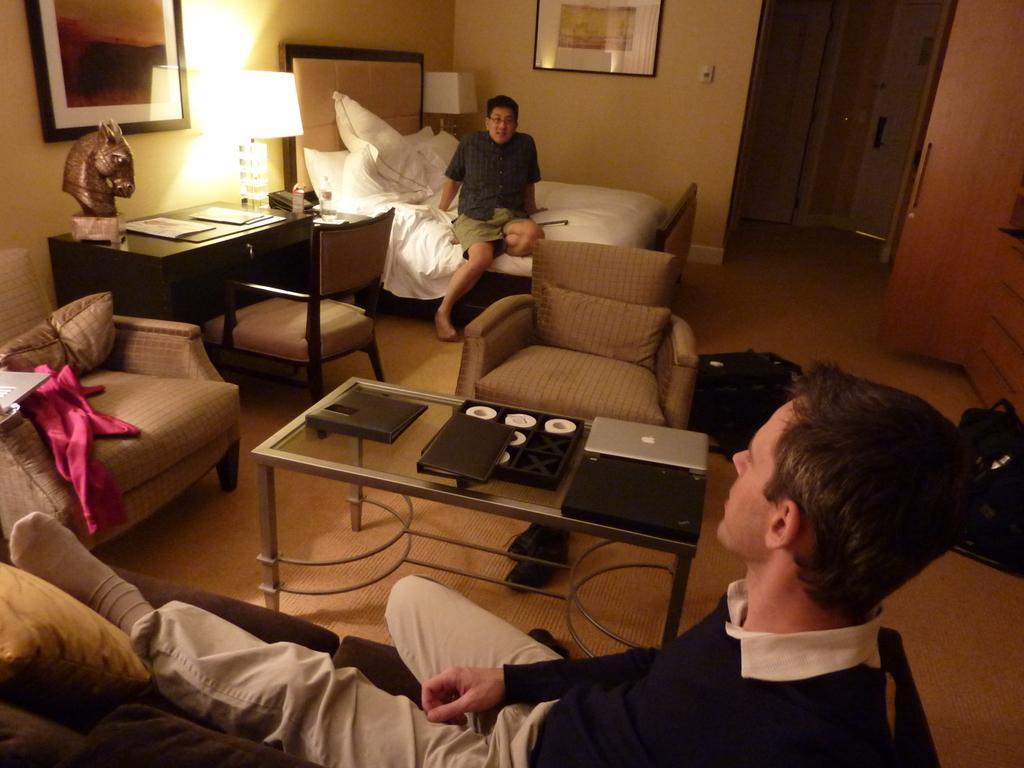In one or two sentences, can you explain what this image depicts? There are two men in this room. A person is sitting on the sofa and a person is sitting on the bed. In between them there are chairs,laptops,plate on a table. and a lamp on the table,statue and on the wall we can see frames. 